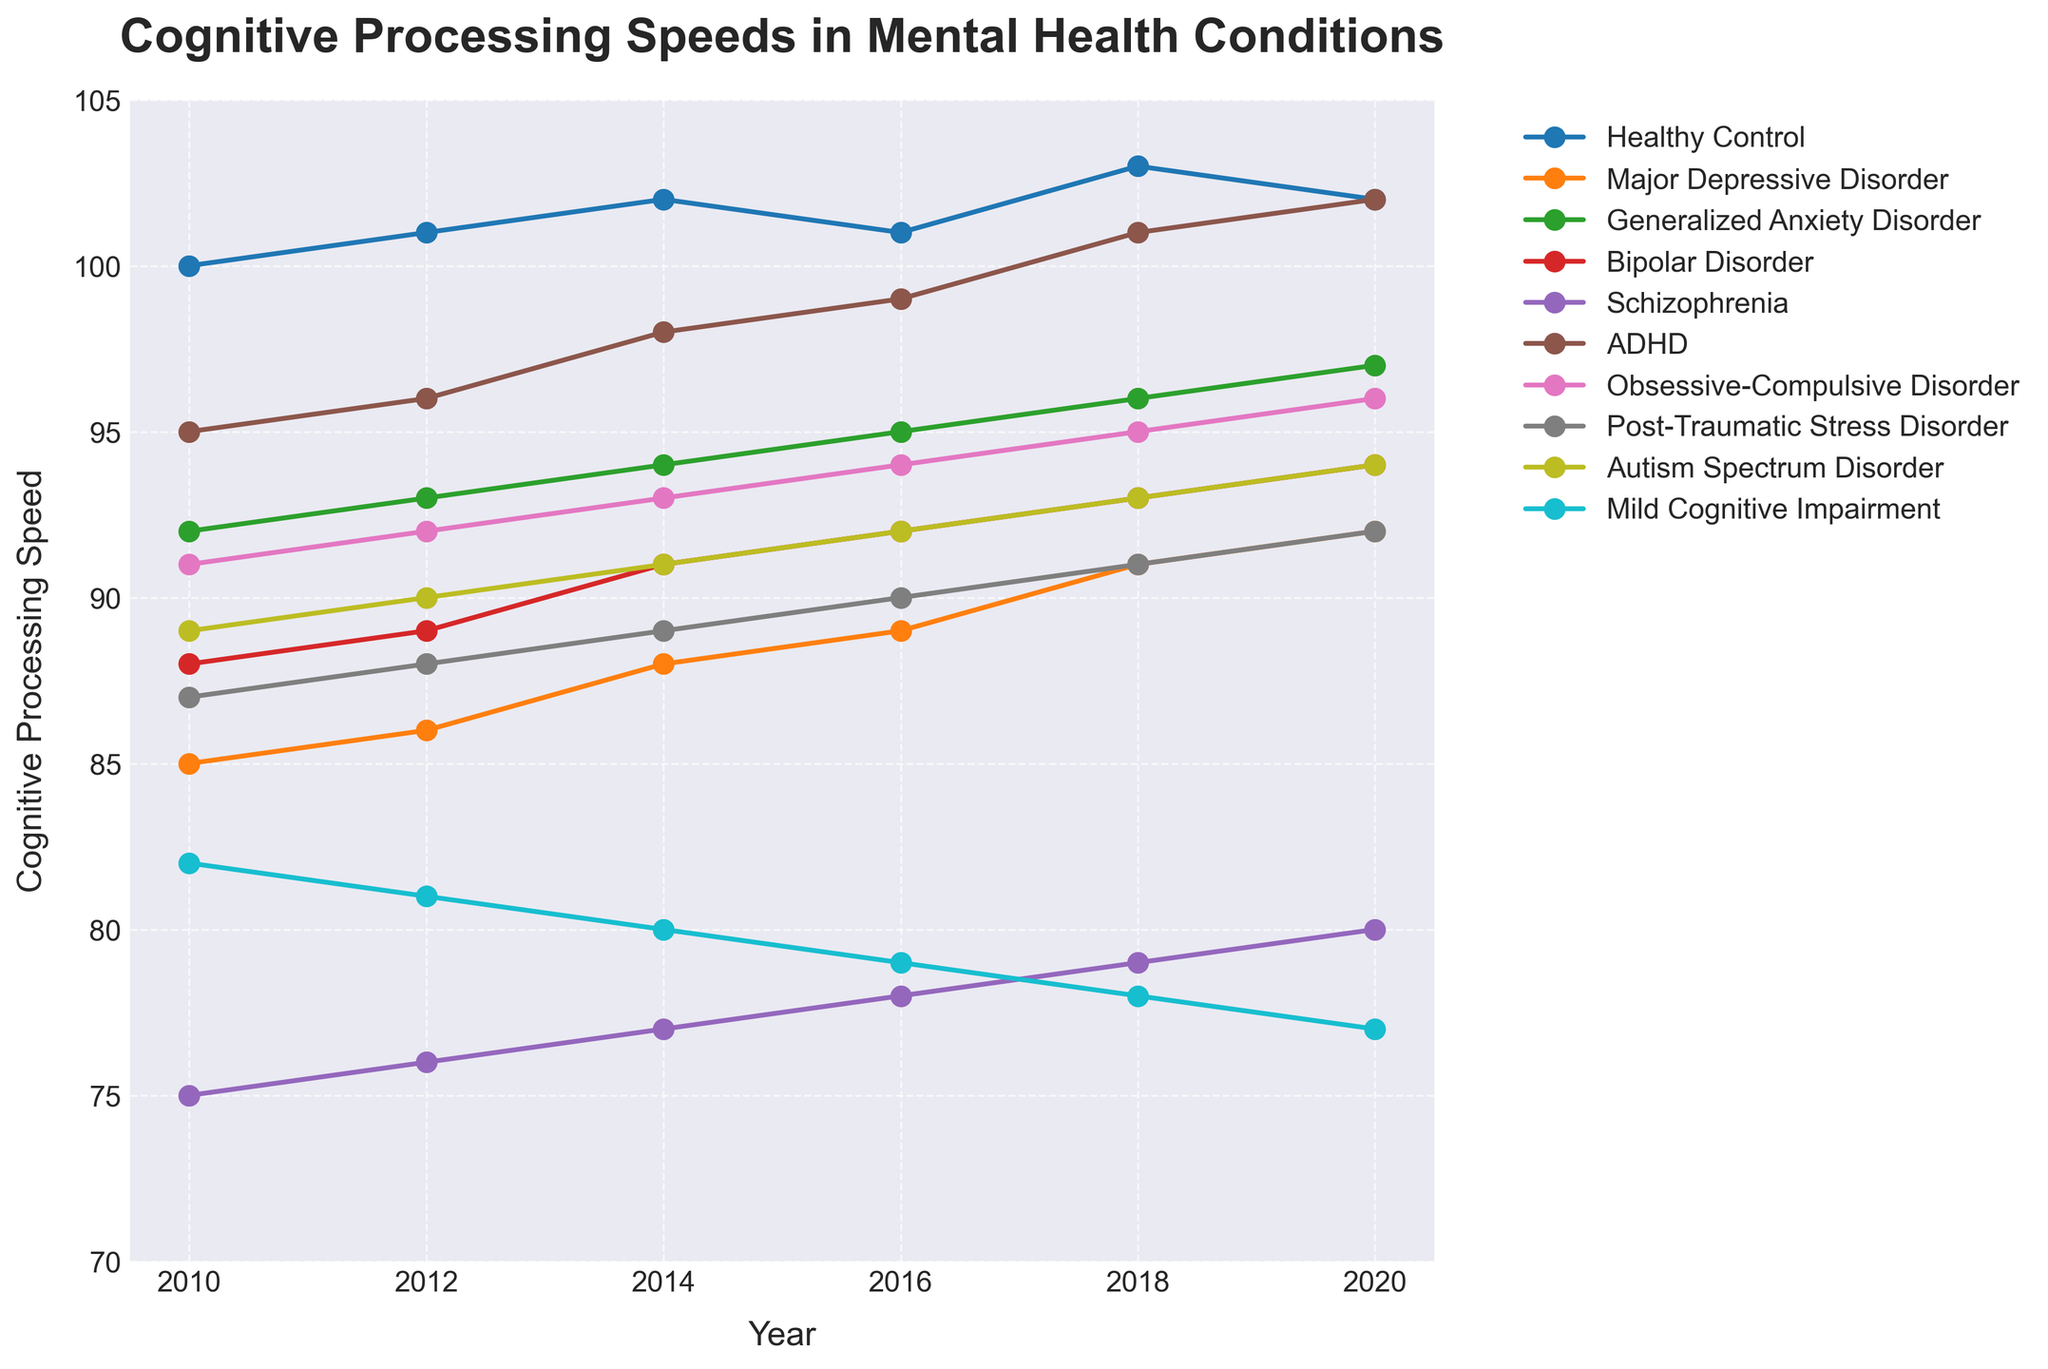what's the average cognitive processing speed of Schizophrenia in the years given? Sum the values: 75 + 76 + 77 + 78 + 79 + 80 = 465. Divide by the number of years: 465 / 6
Answer: 77.5 which year shows the highest cognitive processing speed for Bipolar Disorder? By observing the line representing Bipolar Disorder, the highest value is 94 in the year 2020
Answer: 2020 between Major Depressive Disorder and Generalized Anxiety Disorder, which condition shows greater improvement over the given years? Calculate the difference in values for each condition between 2010 and 2020. Major Depressive Disorder: 92 - 85 = 7. Generalized Anxiety Disorder: 97 - 92 = 5. Major Depressive Disorder shows a greater improvement
Answer: Major Depressive Disorder how does the trend of Mild Cognitive Impairment compare with other conditions between 2010 and 2020? Mild Cognitive Impairment shows a decreasing trend, unlike most other conditions which show a stable or increasing trend
Answer: decreasing trend what is the total increase in cognitive processing speed for ADHD from 2010 to 2020? Calculate the difference between 2020 and 2010: 102 - 95 = 7
Answer: 7 which condition has the lowest cognitive processing speed in 2018? Observing the lines in the chart, Schizophrenia has the lowest value at 79 in 2018
Answer: Schizophrenia compare the cognitive processing speed of Healthy Control in 2010 to Autism Spectrum Disorder in 2010. Which is higher? Healthy Control has a value of 100, while Autism Spectrum Disorder has a value of 89
Answer: Healthy Control is higher how many conditions reached a cognitive processing speed of 94 by 2020? Observing the line chart data, Bipolar Disorder, Generalized Anxiety Disorder, Autism Spectrum Disorder, and Obsessive-Compulsive Disorder with values of 94
Answer: four conditions if we consider Bipolar Disorder and Major Depressive Disorder, which has a higher processing speed in 2016? Bipolar Disorder has a value of 92 in 2016, Major Depressive Disorder has a value of 89
Answer: Bipolar Disorder which condition shows almost a uniform increase over the years provided? Generalized Anxiety Disorder is characterized by nearly uniform increments in the values over the years
Answer: Generalized Anxiety Disorder 